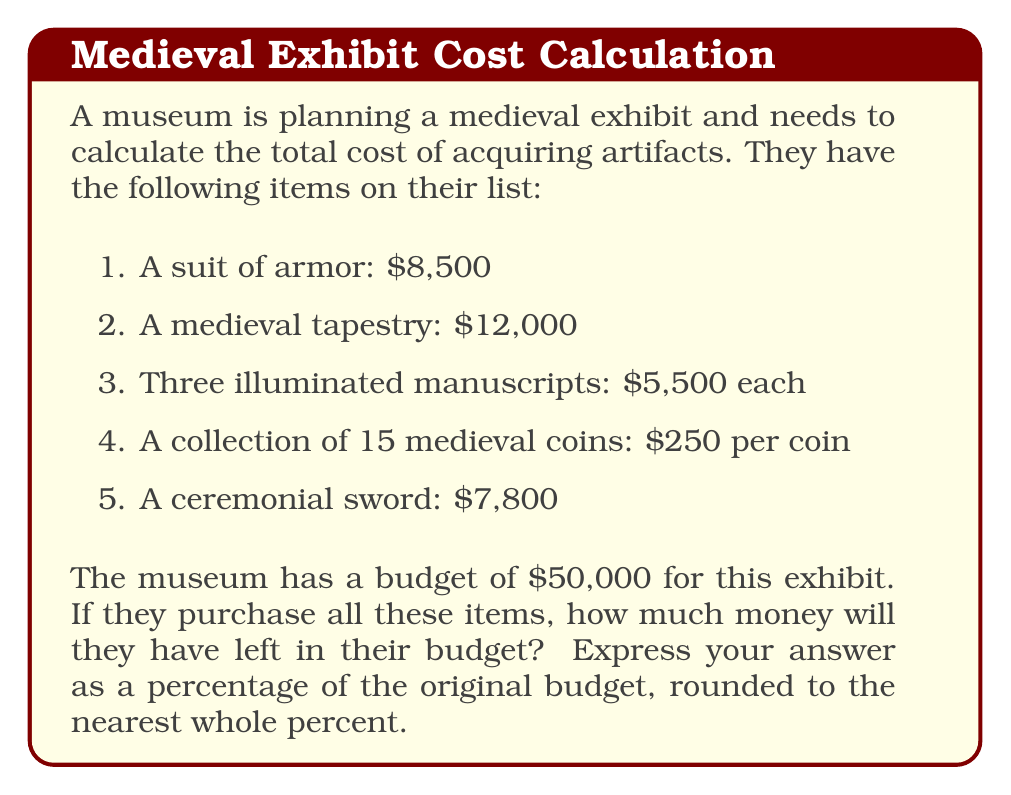Show me your answer to this math problem. Let's break this problem down step-by-step:

1. Calculate the cost of each item:
   - Suit of armor: $8,500
   - Medieval tapestry: $12,000
   - Illuminated manuscripts: $5,500 × 3 = $16,500
   - Medieval coins: $250 × 15 = $3,750
   - Ceremonial sword: $7,800

2. Calculate the total cost of all items:
   $$\text{Total Cost} = 8,500 + 12,000 + 16,500 + 3,750 + 7,800 = $48,550$$

3. Calculate the remaining budget:
   $$\text{Remaining Budget} = 50,000 - 48,550 = $1,450$$

4. Calculate the percentage of the original budget remaining:
   $$\text{Percentage Remaining} = \frac{\text{Remaining Budget}}{\text{Original Budget}} \times 100\%$$
   $$= \frac{1,450}{50,000} \times 100\% = 0.029 \times 100\% = 2.9\%$$

5. Round to the nearest whole percent:
   2.9% rounds to 3%

Therefore, the museum will have 3% of their original budget left after purchasing all the items.
Answer: 3% 